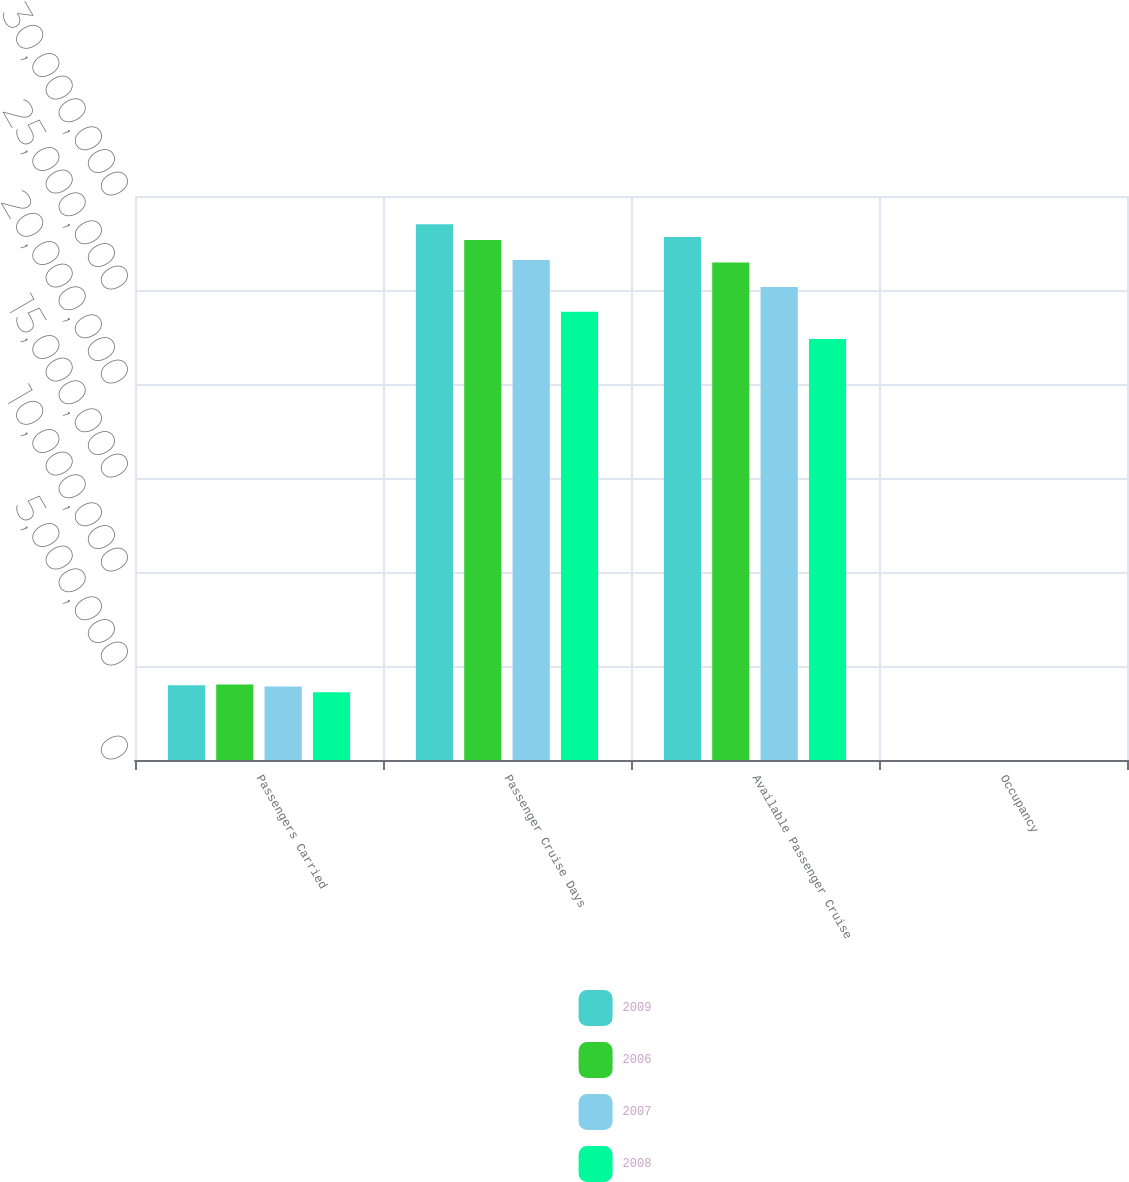Convert chart. <chart><loc_0><loc_0><loc_500><loc_500><stacked_bar_chart><ecel><fcel>Passengers Carried<fcel>Passenger Cruise Days<fcel>Available Passenger Cruise<fcel>Occupancy<nl><fcel>2009<fcel>3.97028e+06<fcel>2.8503e+07<fcel>2.78212e+07<fcel>102.5<nl><fcel>2006<fcel>4.01755e+06<fcel>2.76576e+07<fcel>2.64636e+07<fcel>104.5<nl><fcel>2007<fcel>3.90538e+06<fcel>2.65945e+07<fcel>2.51558e+07<fcel>105.7<nl><fcel>2008<fcel>3.60081e+06<fcel>2.38496e+07<fcel>2.23925e+07<fcel>106.5<nl></chart> 